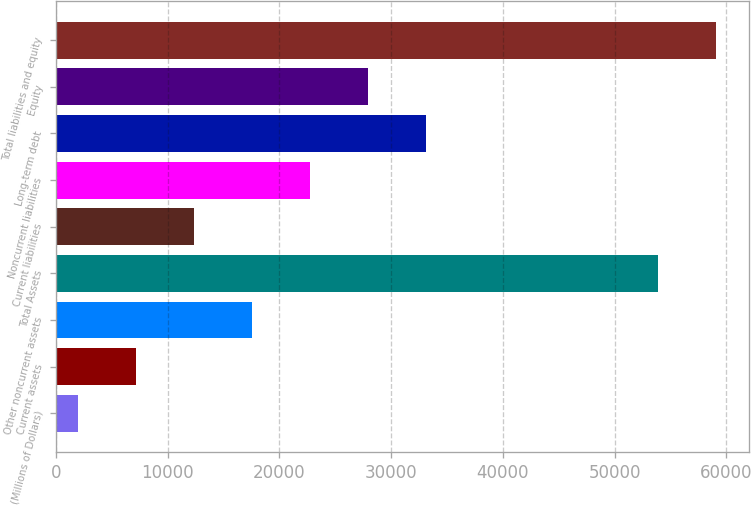Convert chart to OTSL. <chart><loc_0><loc_0><loc_500><loc_500><bar_chart><fcel>(Millions of Dollars)<fcel>Current assets<fcel>Other noncurrent assets<fcel>Total Assets<fcel>Current liabilities<fcel>Noncurrent liabilities<fcel>Long-term debt<fcel>Equity<fcel>Total liabilities and equity<nl><fcel>2018<fcel>7208.2<fcel>17588.6<fcel>53920<fcel>12398.4<fcel>22778.8<fcel>33159.2<fcel>27969<fcel>59110.2<nl></chart> 